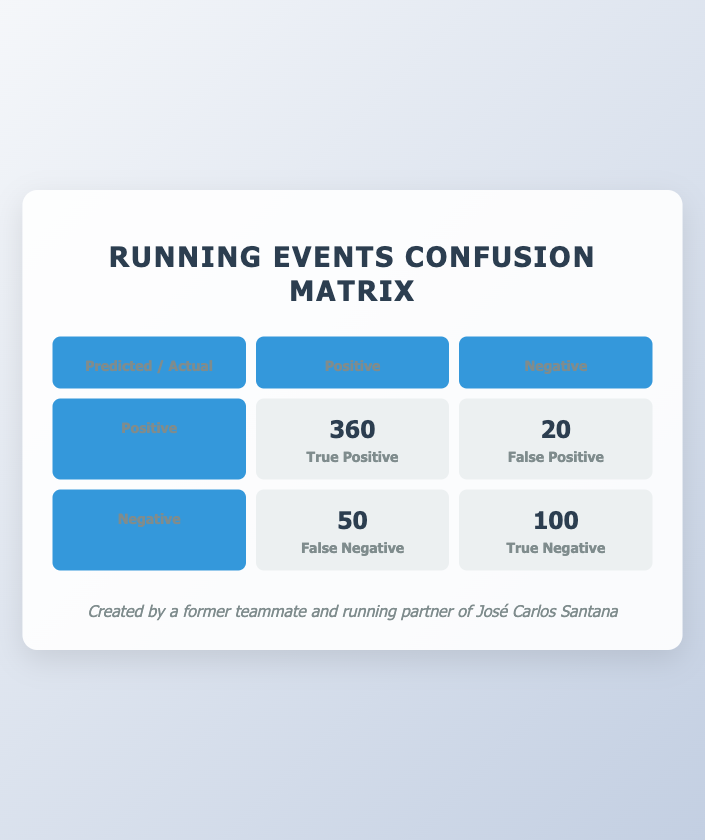What is the number of true positives in the confusion matrix? The confusion matrix indicates the true positive value is 360, which represents the correct predictions of participants who were satisfied and completed the event.
Answer: 360 How many participants in the City Marathon 2023 were dissatisfied? The feedback data for the City Marathon 2023 shows that 80 participants were dissatisfied.
Answer: 80 What is the total number of participants in the Winter Run Fest 2023? The actual outcomes for the Winter Run Fest 2023 shows there were 200 participants.
Answer: 200 What is the difference between true positives and false negatives? The confusion matrix lists true positives as 360 and false negatives as 50. The difference is 360 - 50 = 310.
Answer: 310 Is the number of satisfied participants in the Summer Half Marathon greater than those who did not complete it? The feedback for the Summer Half Marathon indicates 360 satisfied participants, while 20 did not complete the event. Since 360 > 20, the statement is true.
Answer: Yes What percentage of participants completed the Charity 10K Run 2023? To find the completion percentage: 270 completed out of 300 participants. Calculation: (270/300) * 100 = 90%.
Answer: 90% How many more true positives than false positives are there in the confusion matrix? The confusion matrix lists true positives as 360 and false positives as 20. The difference is 360 - 20 = 340.
Answer: 340 What is the average number of satisfied participants across all events? Sum the satisfied participants: 420 + 250 + 360 + 180 = 1210, divided by 4 events gives an average of 1210/4 = 302.5.
Answer: 302.5 Which event had the highest percentage of satisfied participants? Calculate the percentage of satisfied participants for each event: City Marathon 2023 (420/500) = 84%, Charity 10K Run 2023 (250/300) = 83.33%, Summer Half Marathon 2023 (360/400) = 90%, Winter Run Fest 2023 (180/200) = 90%. Both Summer Half Marathon 2023 and Winter Run Fest 2023 have the highest percentage at 90%.
Answer: Summer Half Marathon 2023 & Winter Run Fest 2023 